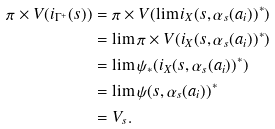<formula> <loc_0><loc_0><loc_500><loc_500>\pi \times V ( i _ { \Gamma ^ { + } } ( s ) ) & = \pi \times V ( \lim i _ { X } ( s , \alpha _ { s } ( a _ { i } ) ) ^ { * } ) \\ & = \lim \pi \times V ( i _ { X } ( s , \alpha _ { s } ( a _ { i } ) ) ^ { * } ) \\ & = \lim \psi _ { * } ( i _ { X } ( s , \alpha _ { s } ( a _ { i } ) ) ^ { * } ) \\ & = \lim \psi ( s , \alpha _ { s } ( a _ { i } ) ) ^ { * } \\ & = V _ { s } .</formula> 